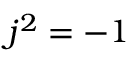<formula> <loc_0><loc_0><loc_500><loc_500>j ^ { 2 } = - 1</formula> 